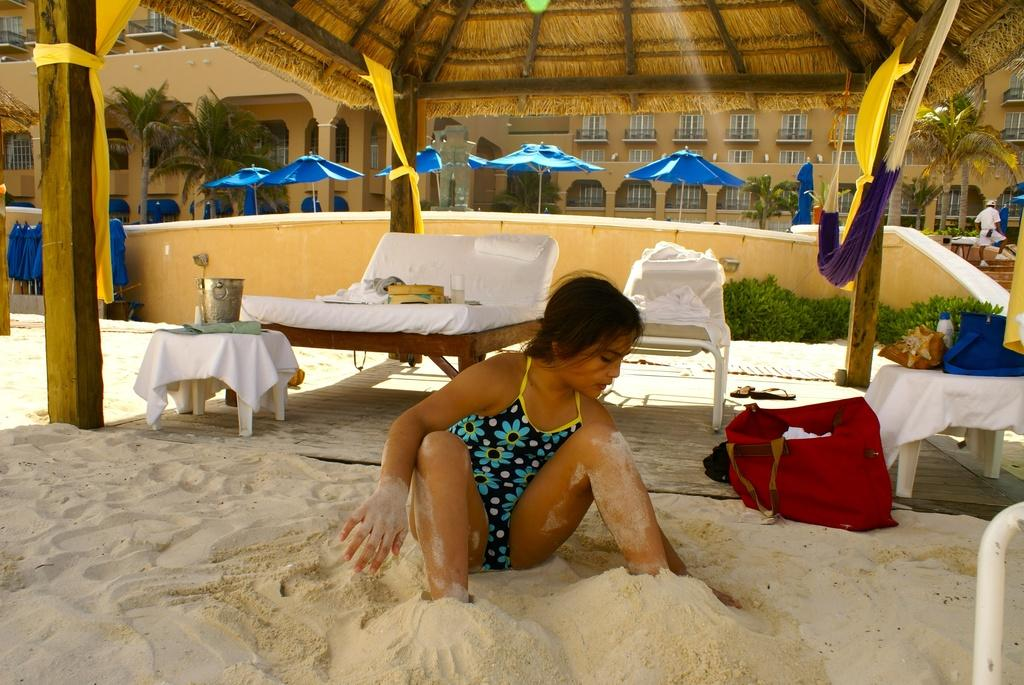What is the person in the image sitting on? The person is sitting on the sand. What type of furniture can be seen in the image? There are chairs and a table in the image. What is the person carrying or holding in the image? There is a bag in the image. What can be seen in the background of the image? There are buildings, a tree, and a tent in the background of the image. What color is the ink used to write on the brass plate in the image? There is no brass plate or ink present in the image. What emotion does the person in the image display when they see the fearful creature in the background? There is no fearful creature present in the image, and the person's emotions cannot be determined from the image. 